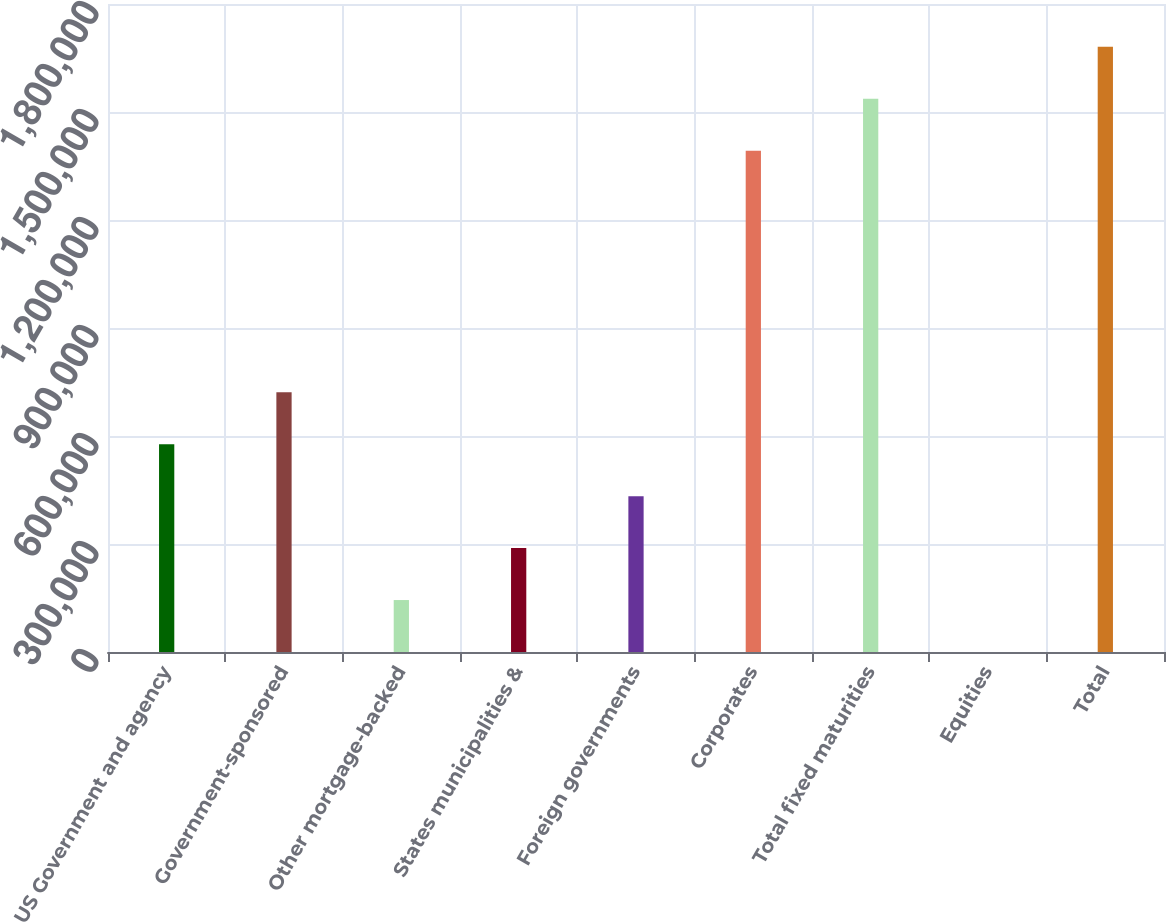Convert chart to OTSL. <chart><loc_0><loc_0><loc_500><loc_500><bar_chart><fcel>US Government and agency<fcel>Government-sponsored<fcel>Other mortgage-backed<fcel>States municipalities &<fcel>Foreign governments<fcel>Corporates<fcel>Total fixed maturities<fcel>Equities<fcel>Total<nl><fcel>577271<fcel>721588<fcel>144320<fcel>288637<fcel>432954<fcel>1.39247e+06<fcel>1.53679e+06<fcel>2.37<fcel>1.6811e+06<nl></chart> 